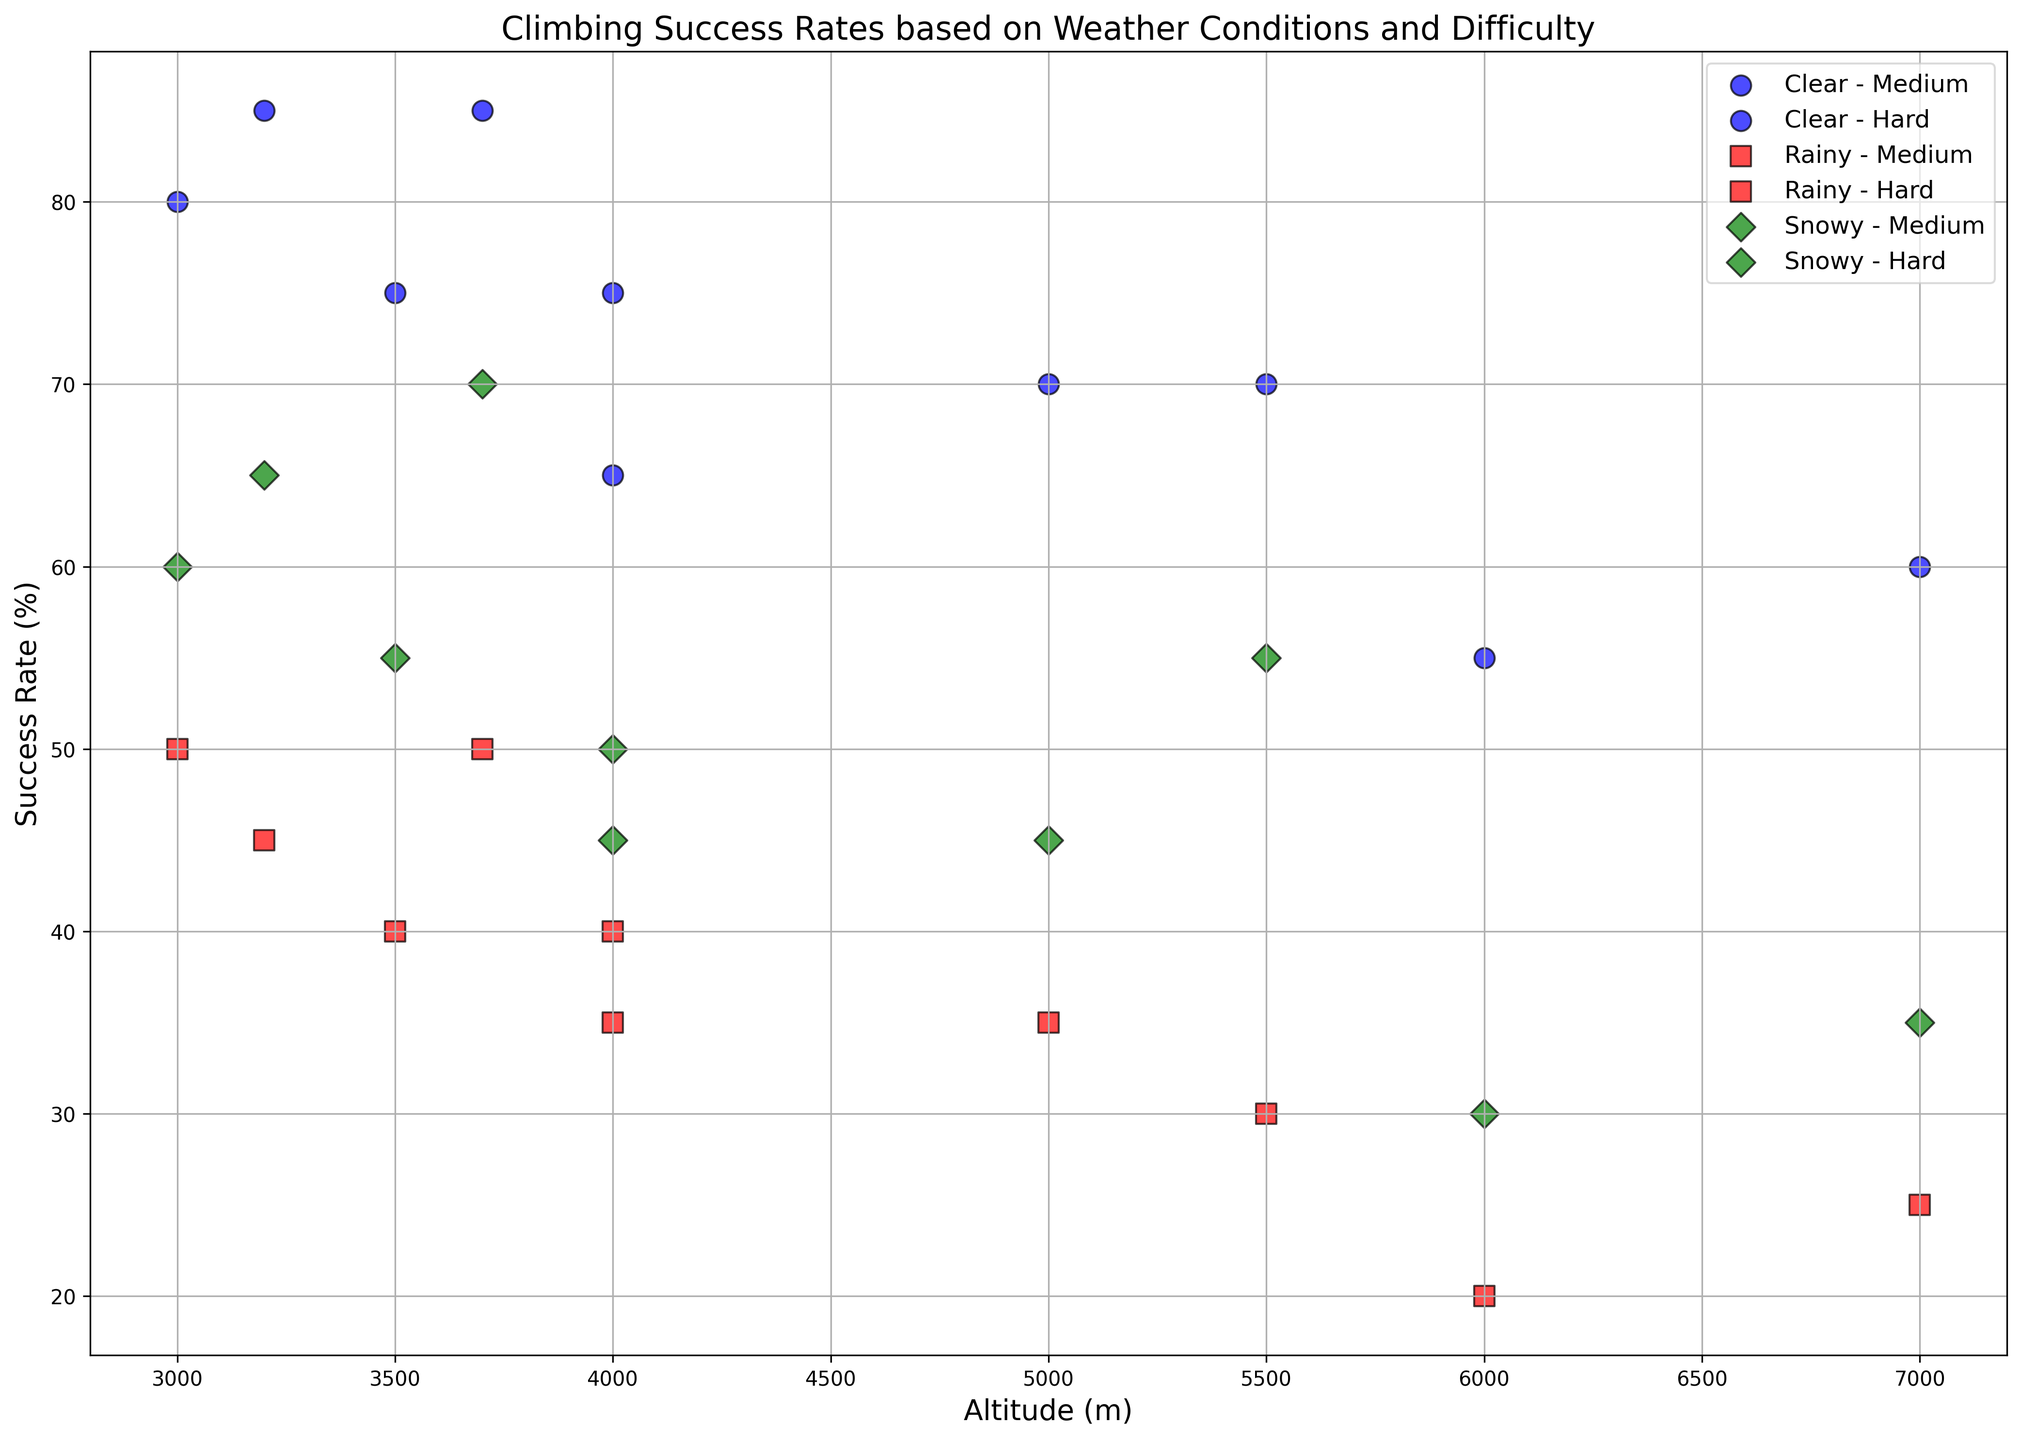What is the success rate for medium difficulty climbs in the Alps under clear weather conditions? To find the success rate, locate the 'Clear' marker for 'Medium' climbs in the Alps. It is at 85% success rate.
Answer: 85% What is the difference in success rates between hard climbs in the Rockies under clear and rainy weather conditions? The success rate for hard climbs in the Rockies under clear weather is 65%, and under rainy weather, it is 35%. The difference is 65% - 35% = 30%.
Answer: 30% Which region shows the highest success rate for medium difficulty climbs under snowy weather conditions? For medium difficulty climbs under snowy weather, the highest success rate can be observed by locating the highest green 'D' marker. The highest rate is in the Caucasus at 70%.
Answer: Caucasus What is the average success rate for hard difficulty climbs in the Himalayas? For hard climbs in the Himalayas, we have success rates of 60% (clear), 25% (rainy), and 35% (snowy). The average is (60+25+35)/3 = 120/3 = 40%.
Answer: 40% Is the success rate for medium difficulty climbs in the Andes higher under clear or snowy weather conditions? For the Andes, medium climbs have 75% success rate under clear weather and 55% under snowy weather. 75% is higher than 55%.
Answer: Clear Which weather condition results in the lowest success rate for hard climbs in the Caucasus? For hard climbs in the Caucasus, the success rates are 70% (clear), 35% (rainy), and 45% (snowy). The lowest is 35% under rainy weather.
Answer: Rainy What are the visual differences in markers used for representing success rates under different weather conditions? The plot uses 'o' markers for clear (blue), 's' markers for rainy (red), and 'D' markers for snowy (green) conditions. These shapes and colors help distinguish different weather conditions visually.
Answer: Circles (blue), Squares (red), Diamonds (green) Compare the overall trend of success rates between medium and hard climbs in all regions under clear weather conditions. Under clear weather, medium climbs generally show higher success rates compared to hard climbs across all regions. Medium climbs success rates: Alps (85%), Himalayas (70%), Rockies (80%), Andes (75%), Caucasus (85%). Hard climbs success rates: Alps (75%), Himalayas (60%), Rockies (65%), Andes (55%), Caucasus (70%). Medium climbs tend to have more success.
Answer: Medium > Hard What is the interquartile range (IQR) of success rates for medium difficulty climbs across all weather conditions and regions? The medium difficulty climbs' success rates are: Alps(85,45,65), Himalayas(70,30,55), Rockies(80,50,60), Andes(75,40,55), Caucasus(85,50,70). Sort these rates: 30, 40, 45, 50, 55, 55, 60, 65, 70, 75, 80, 85, 85. The first quartile (25th percentile) is 50-40=10 (position 4.5). The third quartile (75th percentile) is 75-70=5 (position 10.5). So, IQR = Q3 - Q1 = 5 - 10 = 45%.
Answer: 30 - 75% Under snowy weather, which region has the closest success rates for both medium and hard difficulty climbs? Observe the green 'D' markers for both medium and hard difficulties under snowy weather. The Andes have 55% (medium) and 30% (hard), giving a difference of 25%, the smallest difference among regions.
Answer: Andes 